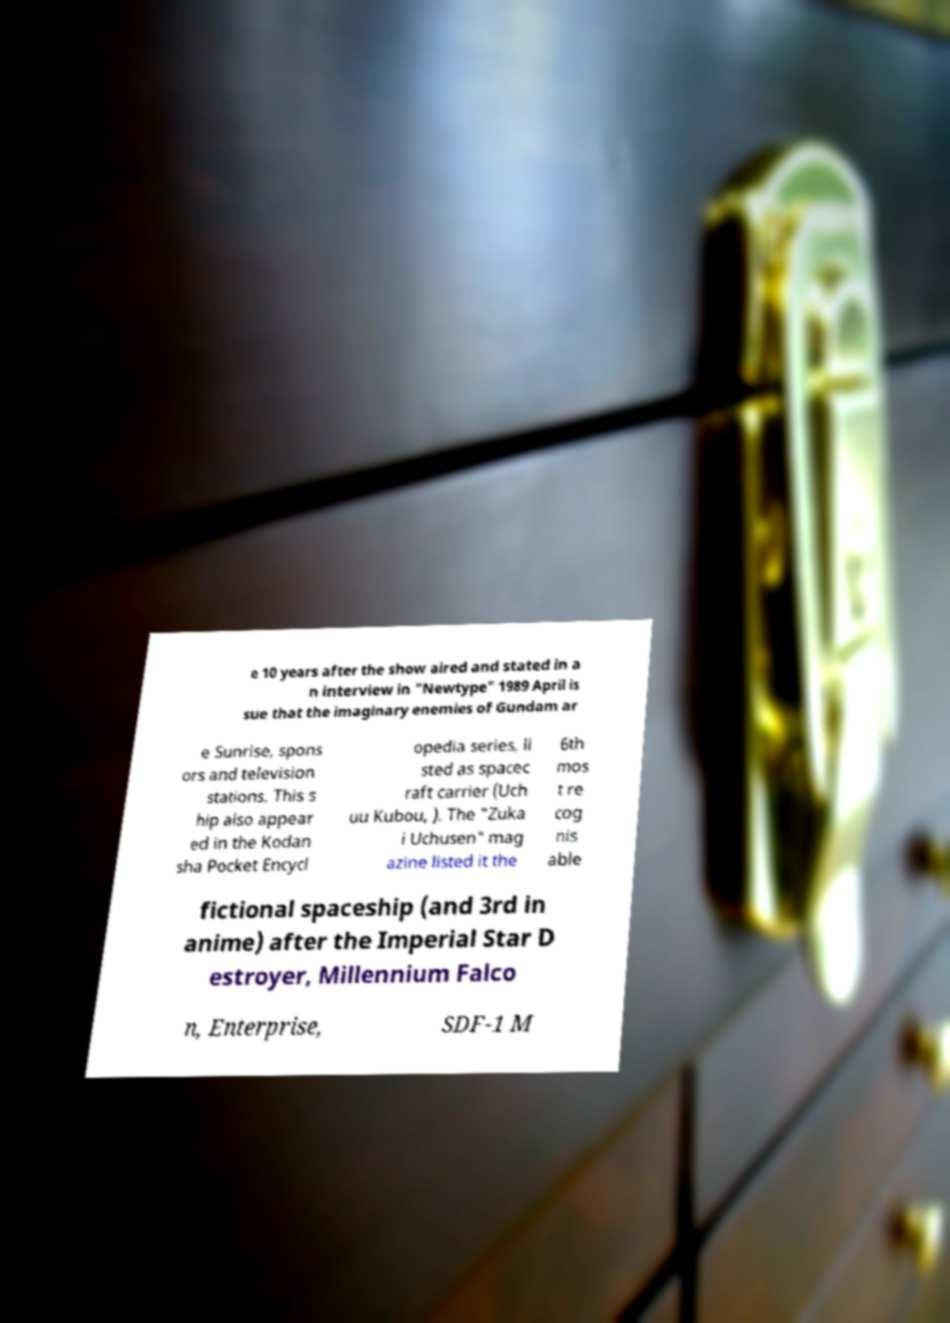Could you extract and type out the text from this image? e 10 years after the show aired and stated in a n interview in "Newtype" 1989 April is sue that the imaginary enemies of Gundam ar e Sunrise, spons ors and television stations. This s hip also appear ed in the Kodan sha Pocket Encycl opedia series, li sted as spacec raft carrier (Uch uu Kubou, ). The "Zuka i Uchusen" mag azine listed it the 6th mos t re cog nis able fictional spaceship (and 3rd in anime) after the Imperial Star D estroyer, Millennium Falco n, Enterprise, SDF-1 M 